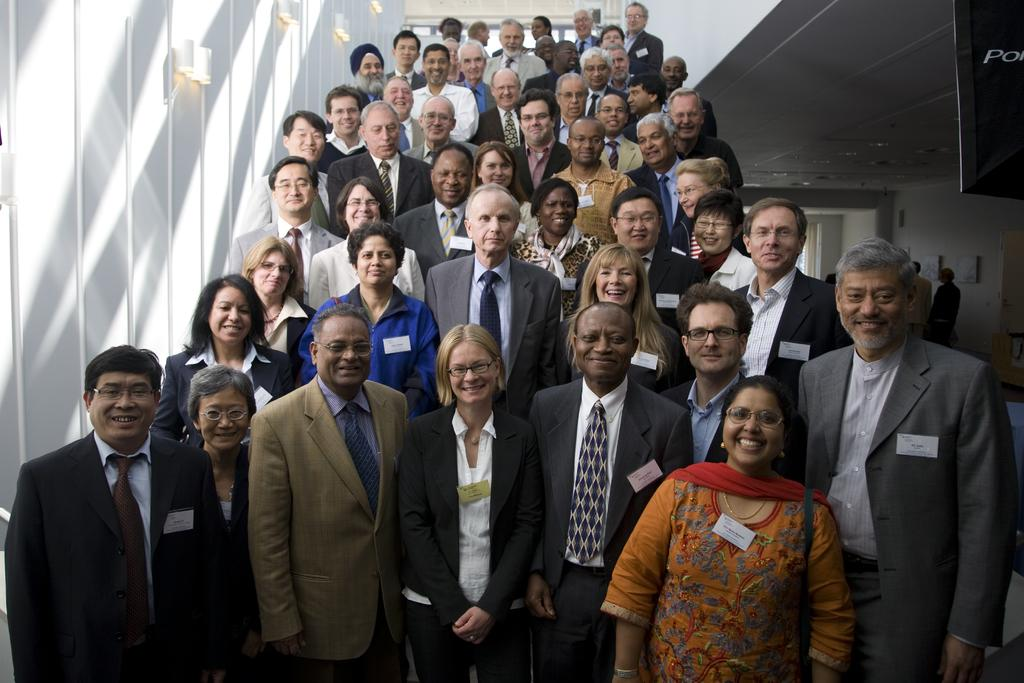Who or what can be seen in the image? There are people in the image. Can you describe the location of the people in the image? The people are standing on a staircase. What type of whip is being used by the people on the staircase? There is no whip present in the image; the people are simply standing on the staircase. 